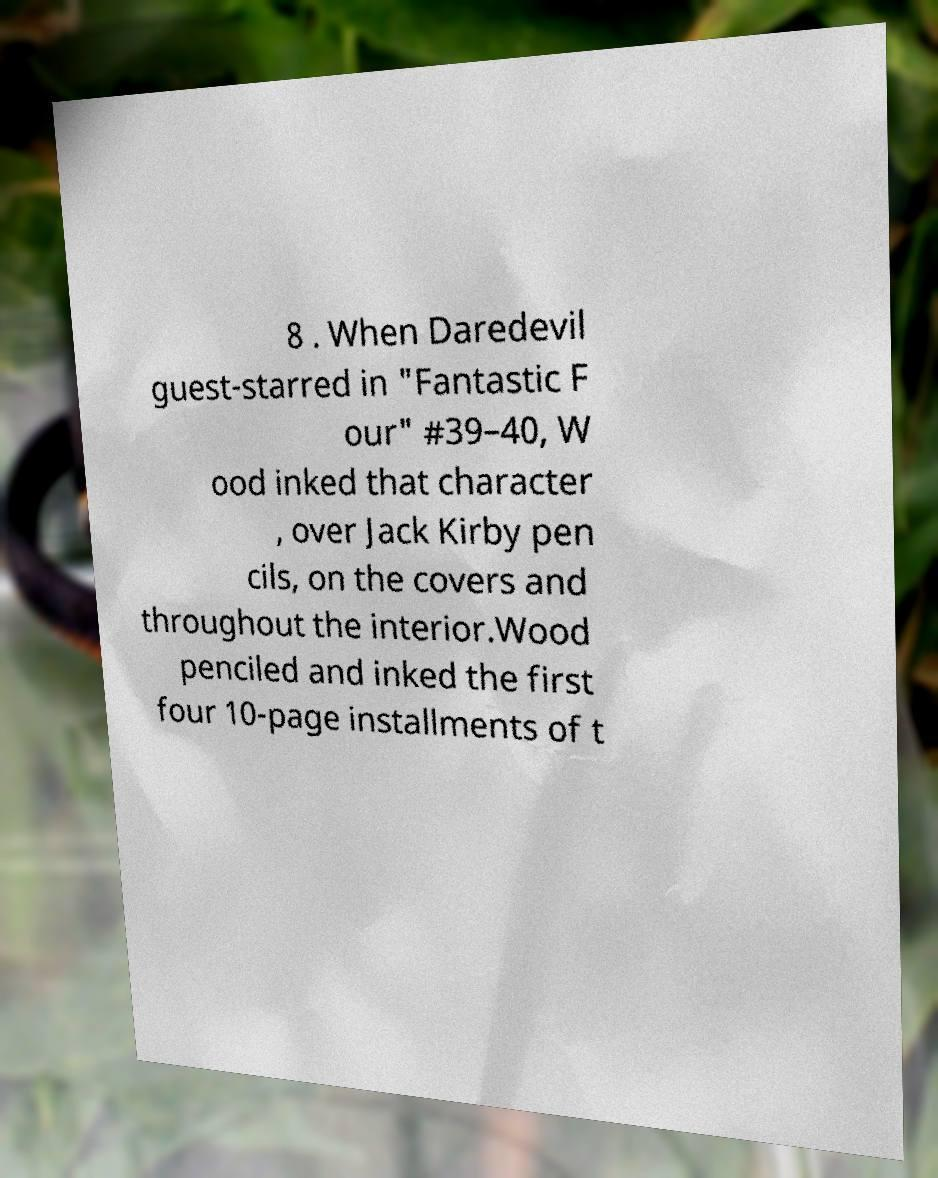Please identify and transcribe the text found in this image. 8 . When Daredevil guest-starred in "Fantastic F our" #39–40, W ood inked that character , over Jack Kirby pen cils, on the covers and throughout the interior.Wood penciled and inked the first four 10-page installments of t 